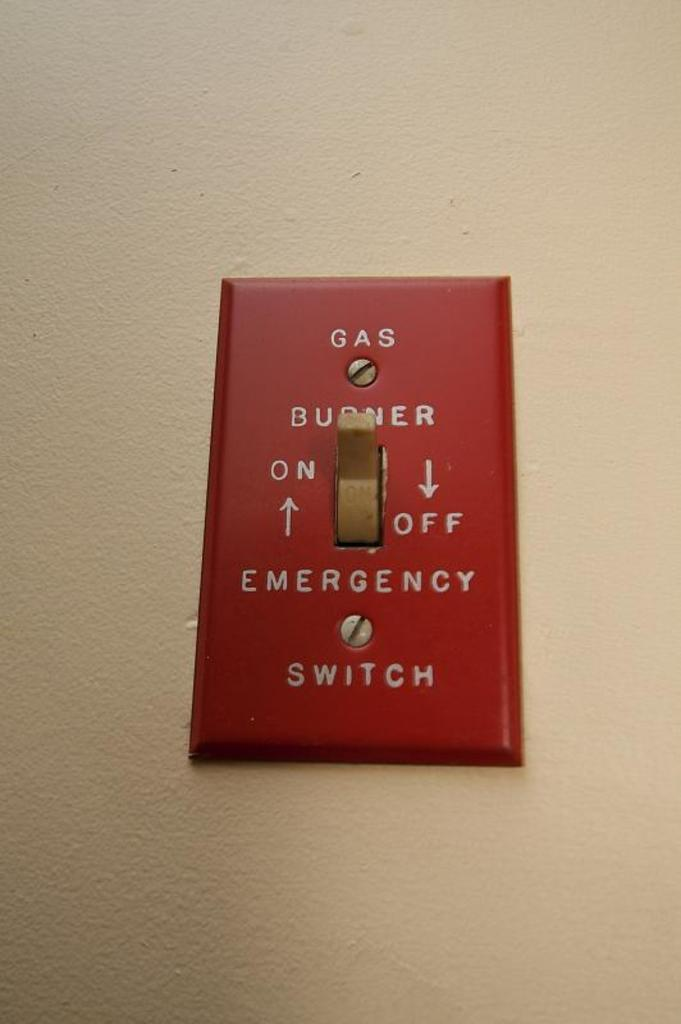<image>
Relay a brief, clear account of the picture shown. A red switch for tuning on and off the gas burner. 